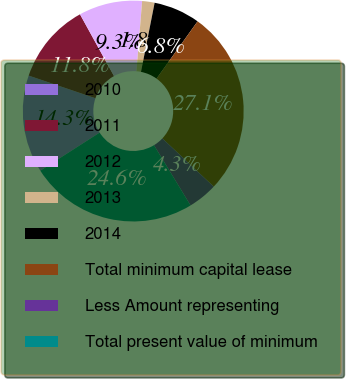Convert chart. <chart><loc_0><loc_0><loc_500><loc_500><pie_chart><fcel>2010<fcel>2011<fcel>2012<fcel>2013<fcel>2014<fcel>Total minimum capital lease<fcel>Less Amount representing<fcel>Total present value of minimum<nl><fcel>14.28%<fcel>11.79%<fcel>9.29%<fcel>1.82%<fcel>6.8%<fcel>27.1%<fcel>4.31%<fcel>24.61%<nl></chart> 